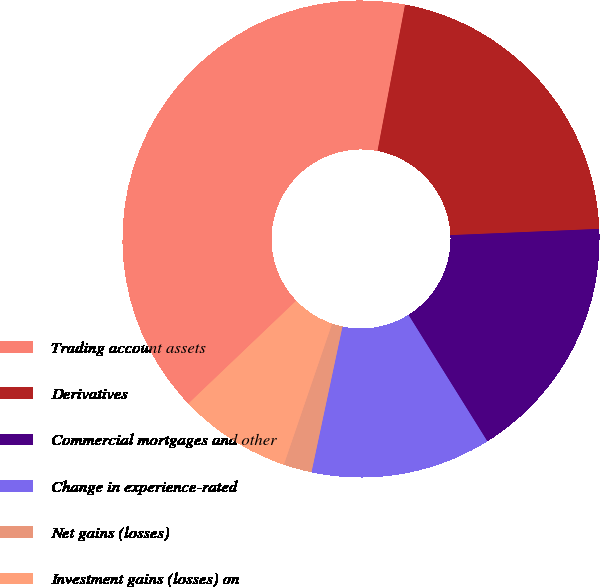Convert chart. <chart><loc_0><loc_0><loc_500><loc_500><pie_chart><fcel>Trading account assets<fcel>Derivatives<fcel>Commercial mortgages and other<fcel>Change in experience-rated<fcel>Net gains (losses)<fcel>Investment gains (losses) on<nl><fcel>40.08%<fcel>21.37%<fcel>16.79%<fcel>12.21%<fcel>1.91%<fcel>7.63%<nl></chart> 